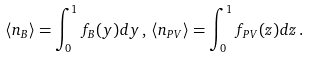<formula> <loc_0><loc_0><loc_500><loc_500>\langle n _ { B } \rangle = \int _ { 0 } ^ { 1 } f _ { B } ( y ) d y \, , \, \langle n _ { P V } \rangle = \int _ { 0 } ^ { 1 } f _ { P V } ( z ) d z \, .</formula> 